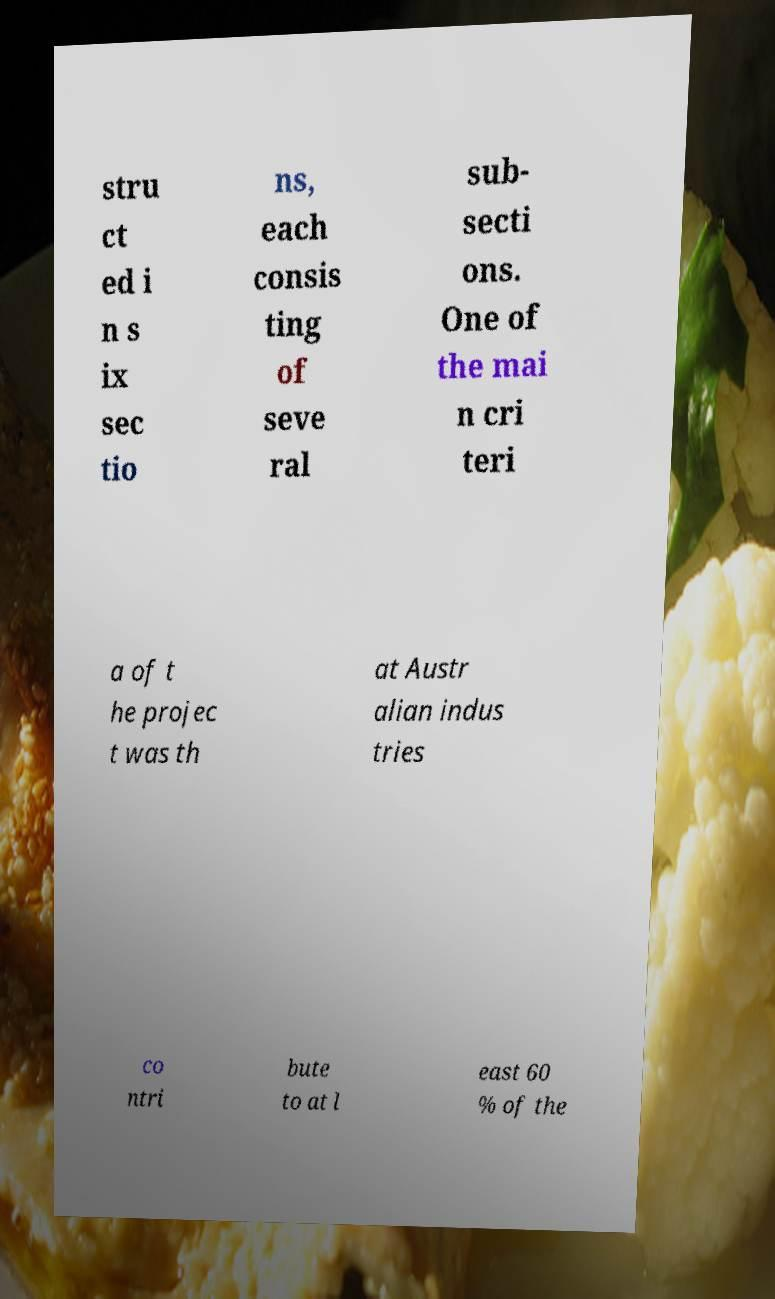Could you assist in decoding the text presented in this image and type it out clearly? stru ct ed i n s ix sec tio ns, each consis ting of seve ral sub- secti ons. One of the mai n cri teri a of t he projec t was th at Austr alian indus tries co ntri bute to at l east 60 % of the 